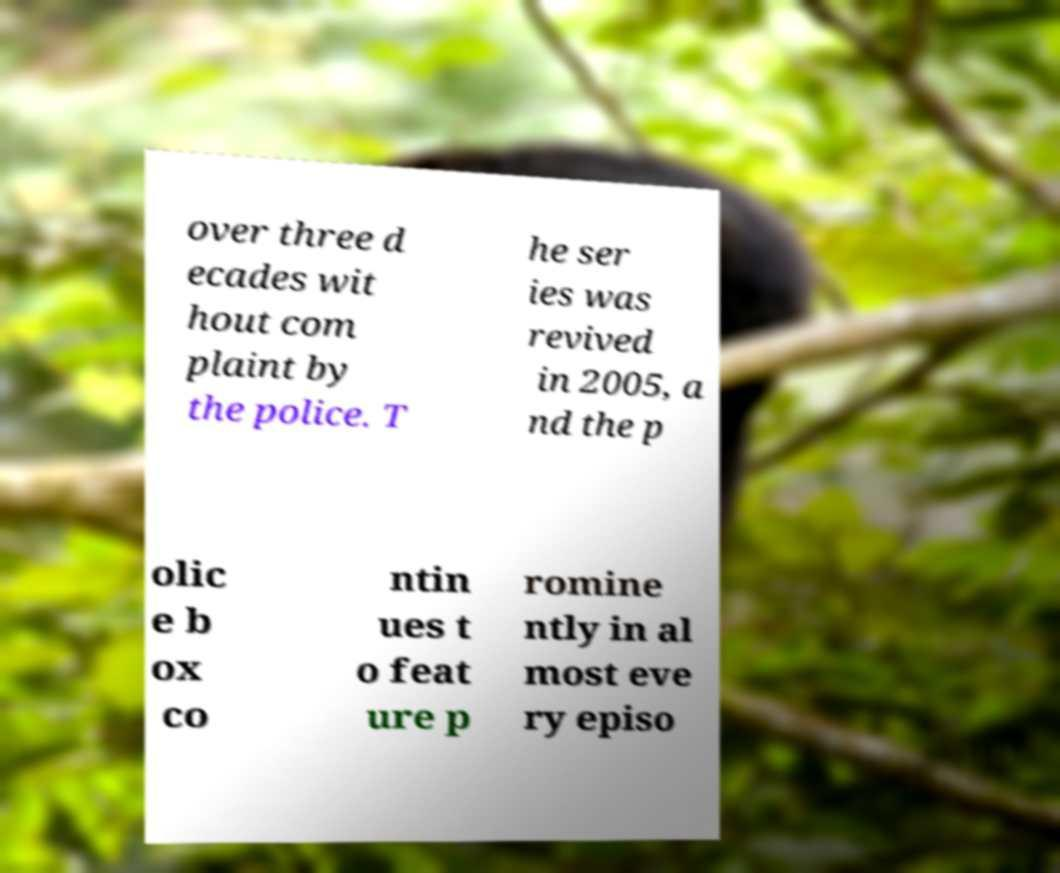What messages or text are displayed in this image? I need them in a readable, typed format. over three d ecades wit hout com plaint by the police. T he ser ies was revived in 2005, a nd the p olic e b ox co ntin ues t o feat ure p romine ntly in al most eve ry episo 